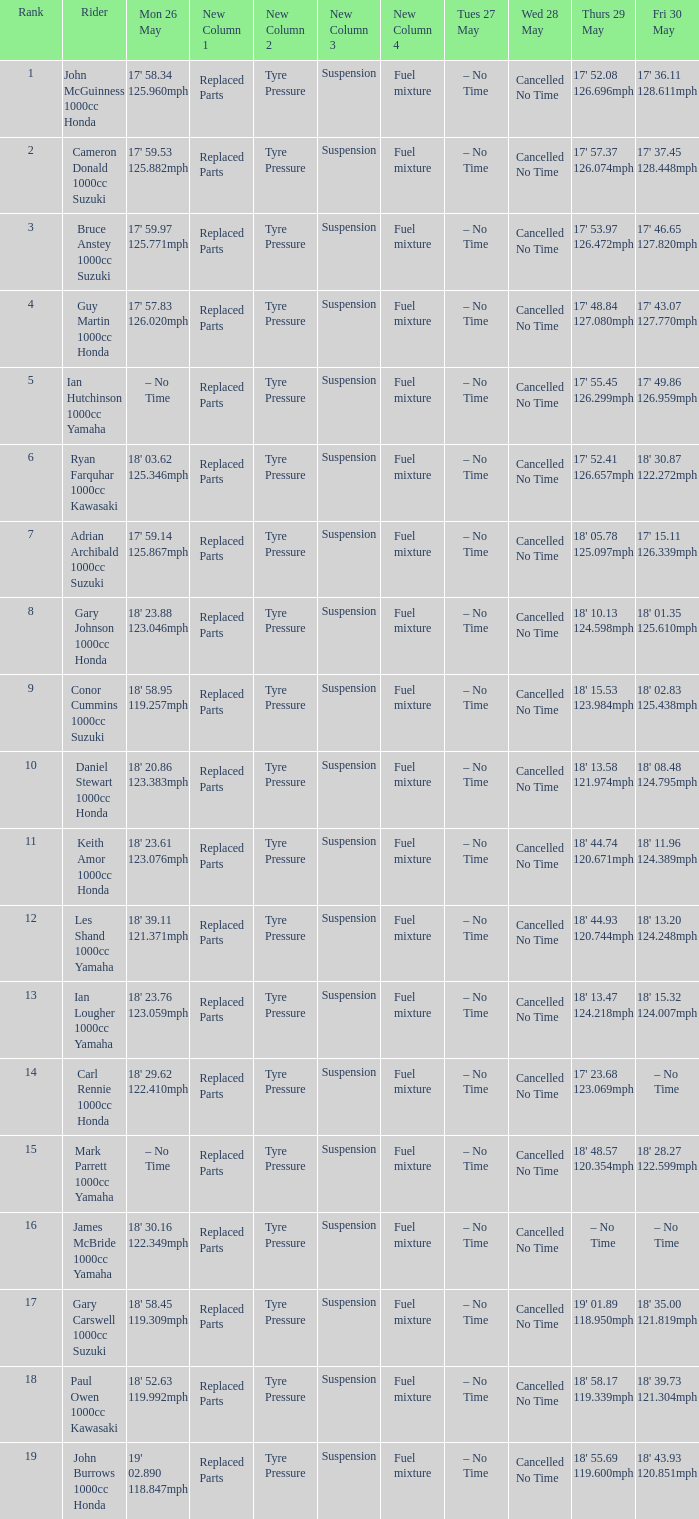What tims is wed may 28 and mon may 26 is 17' 58.34 125.960mph? Cancelled No Time. Give me the full table as a dictionary. {'header': ['Rank', 'Rider', 'Mon 26 May', 'New Column 1', 'New Column 2', 'New Column 3', 'New Column 4', 'Tues 27 May', 'Wed 28 May', 'Thurs 29 May', 'Fri 30 May'], 'rows': [['1', 'John McGuinness 1000cc Honda', "17' 58.34 125.960mph", 'Replaced Parts', 'Tyre Pressure', 'Suspension', 'Fuel mixture', '– No Time', 'Cancelled No Time', "17' 52.08 126.696mph", "17' 36.11 128.611mph"], ['2', 'Cameron Donald 1000cc Suzuki', "17' 59.53 125.882mph", 'Replaced Parts', 'Tyre Pressure', 'Suspension', 'Fuel mixture', '– No Time', 'Cancelled No Time', "17' 57.37 126.074mph", "17' 37.45 128.448mph"], ['3', 'Bruce Anstey 1000cc Suzuki', "17' 59.97 125.771mph", 'Replaced Parts', 'Tyre Pressure', 'Suspension', 'Fuel mixture', '– No Time', 'Cancelled No Time', "17' 53.97 126.472mph", "17' 46.65 127.820mph"], ['4', 'Guy Martin 1000cc Honda', "17' 57.83 126.020mph", 'Replaced Parts', 'Tyre Pressure', 'Suspension', 'Fuel mixture', '– No Time', 'Cancelled No Time', "17' 48.84 127.080mph", "17' 43.07 127.770mph"], ['5', 'Ian Hutchinson 1000cc Yamaha', '– No Time', 'Replaced Parts', 'Tyre Pressure', 'Suspension', 'Fuel mixture', '– No Time', 'Cancelled No Time', "17' 55.45 126.299mph", "17' 49.86 126.959mph"], ['6', 'Ryan Farquhar 1000cc Kawasaki', "18' 03.62 125.346mph", 'Replaced Parts', 'Tyre Pressure', 'Suspension', 'Fuel mixture', '– No Time', 'Cancelled No Time', "17' 52.41 126.657mph", "18' 30.87 122.272mph"], ['7', 'Adrian Archibald 1000cc Suzuki', "17' 59.14 125.867mph", 'Replaced Parts', 'Tyre Pressure', 'Suspension', 'Fuel mixture', '– No Time', 'Cancelled No Time', "18' 05.78 125.097mph", "17' 15.11 126.339mph"], ['8', 'Gary Johnson 1000cc Honda', "18' 23.88 123.046mph", 'Replaced Parts', 'Tyre Pressure', 'Suspension', 'Fuel mixture', '– No Time', 'Cancelled No Time', "18' 10.13 124.598mph", "18' 01.35 125.610mph"], ['9', 'Conor Cummins 1000cc Suzuki', "18' 58.95 119.257mph", 'Replaced Parts', 'Tyre Pressure', 'Suspension', 'Fuel mixture', '– No Time', 'Cancelled No Time', "18' 15.53 123.984mph", "18' 02.83 125.438mph"], ['10', 'Daniel Stewart 1000cc Honda', "18' 20.86 123.383mph", 'Replaced Parts', 'Tyre Pressure', 'Suspension', 'Fuel mixture', '– No Time', 'Cancelled No Time', "18' 13.58 121.974mph", "18' 08.48 124.795mph"], ['11', 'Keith Amor 1000cc Honda', "18' 23.61 123.076mph", 'Replaced Parts', 'Tyre Pressure', 'Suspension', 'Fuel mixture', '– No Time', 'Cancelled No Time', "18' 44.74 120.671mph", "18' 11.96 124.389mph"], ['12', 'Les Shand 1000cc Yamaha', "18' 39.11 121.371mph", 'Replaced Parts', 'Tyre Pressure', 'Suspension', 'Fuel mixture', '– No Time', 'Cancelled No Time', "18' 44.93 120.744mph", "18' 13.20 124.248mph"], ['13', 'Ian Lougher 1000cc Yamaha', "18' 23.76 123.059mph", 'Replaced Parts', 'Tyre Pressure', 'Suspension', 'Fuel mixture', '– No Time', 'Cancelled No Time', "18' 13.47 124.218mph", "18' 15.32 124.007mph"], ['14', 'Carl Rennie 1000cc Honda', "18' 29.62 122.410mph", 'Replaced Parts', 'Tyre Pressure', 'Suspension', 'Fuel mixture', '– No Time', 'Cancelled No Time', "17' 23.68 123.069mph", '– No Time'], ['15', 'Mark Parrett 1000cc Yamaha', '– No Time', 'Replaced Parts', 'Tyre Pressure', 'Suspension', 'Fuel mixture', '– No Time', 'Cancelled No Time', "18' 48.57 120.354mph", "18' 28.27 122.599mph"], ['16', 'James McBride 1000cc Yamaha', "18' 30.16 122.349mph", 'Replaced Parts', 'Tyre Pressure', 'Suspension', 'Fuel mixture', '– No Time', 'Cancelled No Time', '– No Time', '– No Time'], ['17', 'Gary Carswell 1000cc Suzuki', "18' 58.45 119.309mph", 'Replaced Parts', 'Tyre Pressure', 'Suspension', 'Fuel mixture', '– No Time', 'Cancelled No Time', "19' 01.89 118.950mph", "18' 35.00 121.819mph"], ['18', 'Paul Owen 1000cc Kawasaki', "18' 52.63 119.992mph", 'Replaced Parts', 'Tyre Pressure', 'Suspension', 'Fuel mixture', '– No Time', 'Cancelled No Time', "18' 58.17 119.339mph", "18' 39.73 121.304mph"], ['19', 'John Burrows 1000cc Honda', "19' 02.890 118.847mph", 'Replaced Parts', 'Tyre Pressure', 'Suspension', 'Fuel mixture', '– No Time', 'Cancelled No Time', "18' 55.69 119.600mph", "18' 43.93 120.851mph"]]} 